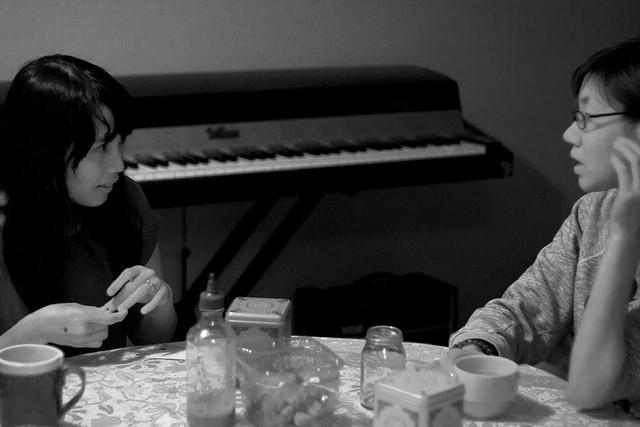What type musician lives here?
Answer the question by selecting the correct answer among the 4 following choices and explain your choice with a short sentence. The answer should be formatted with the following format: `Answer: choice
Rationale: rationale.`
Options: Violinist, triangle player, percussionist, pianist. Answer: pianist.
Rationale: It is a pianist because a piano is against the wall 